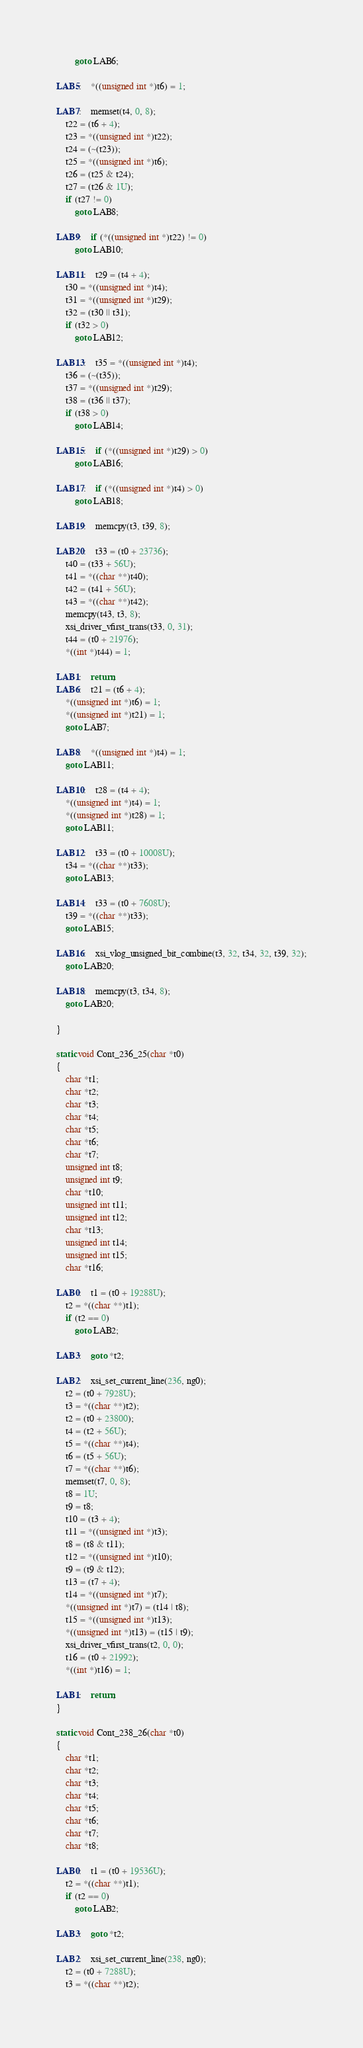Convert code to text. <code><loc_0><loc_0><loc_500><loc_500><_C_>        goto LAB6;

LAB5:    *((unsigned int *)t6) = 1;

LAB7:    memset(t4, 0, 8);
    t22 = (t6 + 4);
    t23 = *((unsigned int *)t22);
    t24 = (~(t23));
    t25 = *((unsigned int *)t6);
    t26 = (t25 & t24);
    t27 = (t26 & 1U);
    if (t27 != 0)
        goto LAB8;

LAB9:    if (*((unsigned int *)t22) != 0)
        goto LAB10;

LAB11:    t29 = (t4 + 4);
    t30 = *((unsigned int *)t4);
    t31 = *((unsigned int *)t29);
    t32 = (t30 || t31);
    if (t32 > 0)
        goto LAB12;

LAB13:    t35 = *((unsigned int *)t4);
    t36 = (~(t35));
    t37 = *((unsigned int *)t29);
    t38 = (t36 || t37);
    if (t38 > 0)
        goto LAB14;

LAB15:    if (*((unsigned int *)t29) > 0)
        goto LAB16;

LAB17:    if (*((unsigned int *)t4) > 0)
        goto LAB18;

LAB19:    memcpy(t3, t39, 8);

LAB20:    t33 = (t0 + 23736);
    t40 = (t33 + 56U);
    t41 = *((char **)t40);
    t42 = (t41 + 56U);
    t43 = *((char **)t42);
    memcpy(t43, t3, 8);
    xsi_driver_vfirst_trans(t33, 0, 31);
    t44 = (t0 + 21976);
    *((int *)t44) = 1;

LAB1:    return;
LAB6:    t21 = (t6 + 4);
    *((unsigned int *)t6) = 1;
    *((unsigned int *)t21) = 1;
    goto LAB7;

LAB8:    *((unsigned int *)t4) = 1;
    goto LAB11;

LAB10:    t28 = (t4 + 4);
    *((unsigned int *)t4) = 1;
    *((unsigned int *)t28) = 1;
    goto LAB11;

LAB12:    t33 = (t0 + 10008U);
    t34 = *((char **)t33);
    goto LAB13;

LAB14:    t33 = (t0 + 7608U);
    t39 = *((char **)t33);
    goto LAB15;

LAB16:    xsi_vlog_unsigned_bit_combine(t3, 32, t34, 32, t39, 32);
    goto LAB20;

LAB18:    memcpy(t3, t34, 8);
    goto LAB20;

}

static void Cont_236_25(char *t0)
{
    char *t1;
    char *t2;
    char *t3;
    char *t4;
    char *t5;
    char *t6;
    char *t7;
    unsigned int t8;
    unsigned int t9;
    char *t10;
    unsigned int t11;
    unsigned int t12;
    char *t13;
    unsigned int t14;
    unsigned int t15;
    char *t16;

LAB0:    t1 = (t0 + 19288U);
    t2 = *((char **)t1);
    if (t2 == 0)
        goto LAB2;

LAB3:    goto *t2;

LAB2:    xsi_set_current_line(236, ng0);
    t2 = (t0 + 7928U);
    t3 = *((char **)t2);
    t2 = (t0 + 23800);
    t4 = (t2 + 56U);
    t5 = *((char **)t4);
    t6 = (t5 + 56U);
    t7 = *((char **)t6);
    memset(t7, 0, 8);
    t8 = 1U;
    t9 = t8;
    t10 = (t3 + 4);
    t11 = *((unsigned int *)t3);
    t8 = (t8 & t11);
    t12 = *((unsigned int *)t10);
    t9 = (t9 & t12);
    t13 = (t7 + 4);
    t14 = *((unsigned int *)t7);
    *((unsigned int *)t7) = (t14 | t8);
    t15 = *((unsigned int *)t13);
    *((unsigned int *)t13) = (t15 | t9);
    xsi_driver_vfirst_trans(t2, 0, 0);
    t16 = (t0 + 21992);
    *((int *)t16) = 1;

LAB1:    return;
}

static void Cont_238_26(char *t0)
{
    char *t1;
    char *t2;
    char *t3;
    char *t4;
    char *t5;
    char *t6;
    char *t7;
    char *t8;

LAB0:    t1 = (t0 + 19536U);
    t2 = *((char **)t1);
    if (t2 == 0)
        goto LAB2;

LAB3:    goto *t2;

LAB2:    xsi_set_current_line(238, ng0);
    t2 = (t0 + 7288U);
    t3 = *((char **)t2);</code> 